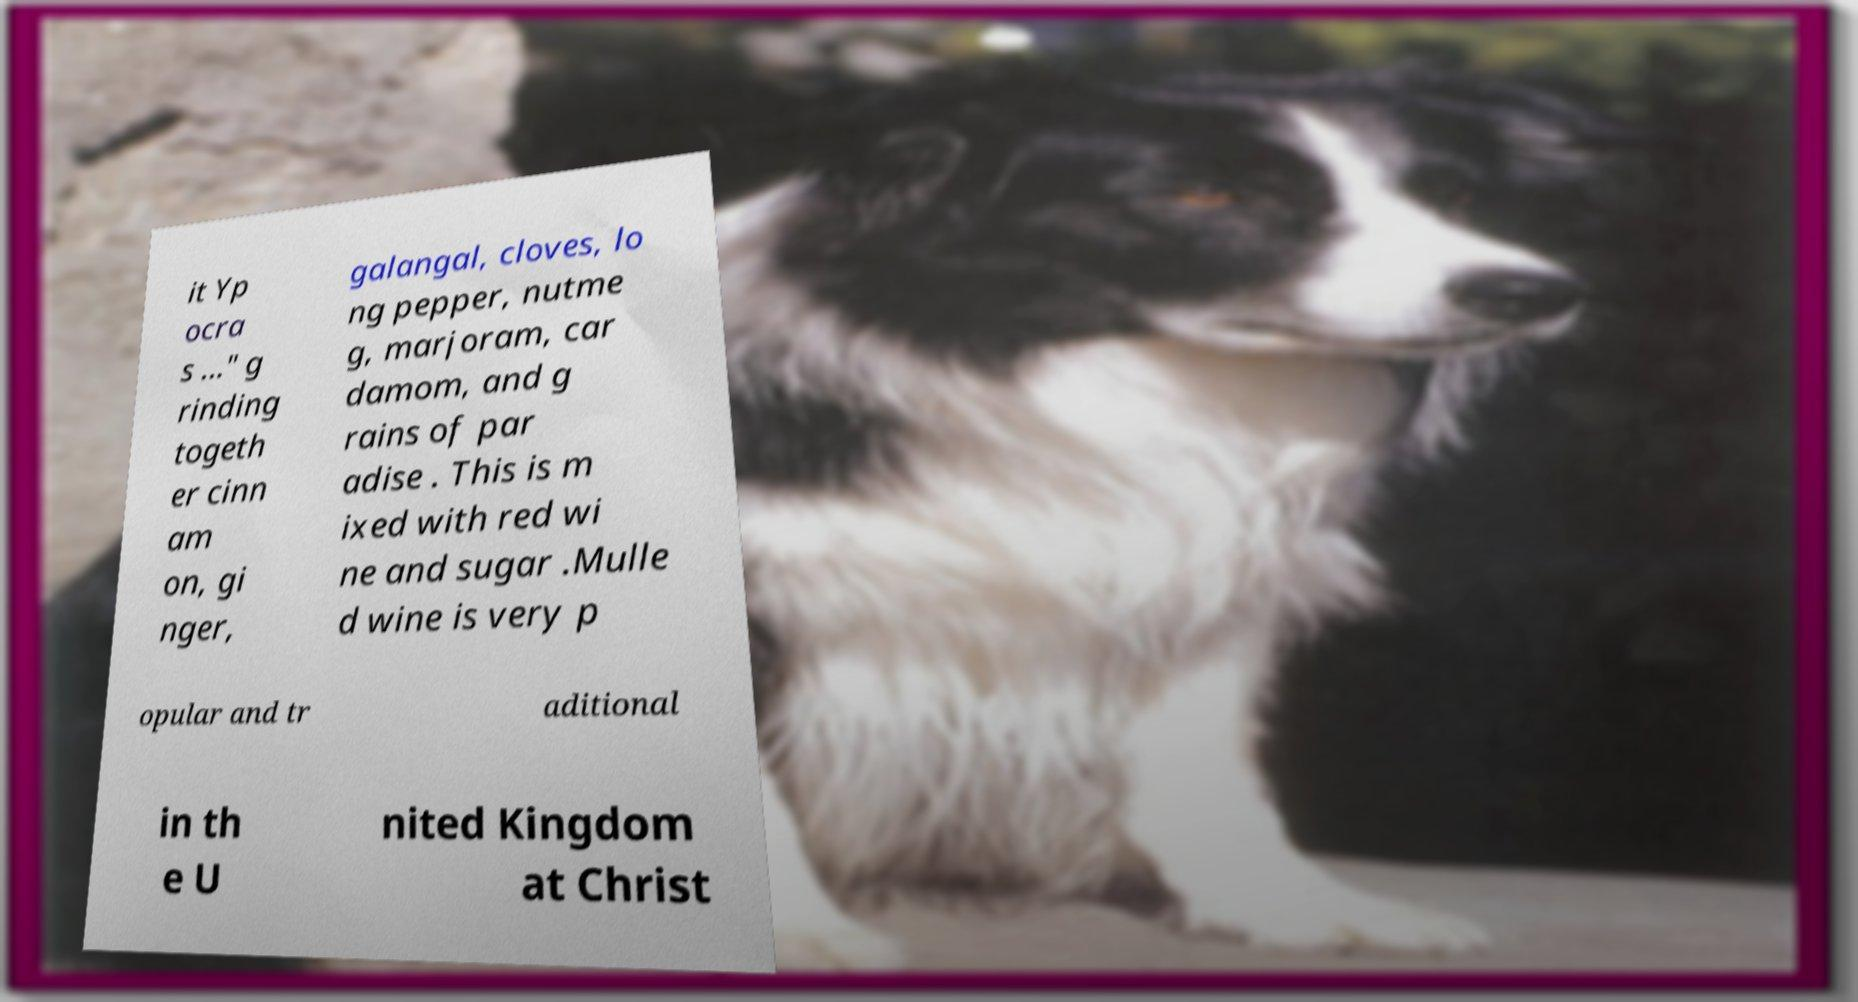Could you extract and type out the text from this image? it Yp ocra s ..." g rinding togeth er cinn am on, gi nger, galangal, cloves, lo ng pepper, nutme g, marjoram, car damom, and g rains of par adise . This is m ixed with red wi ne and sugar .Mulle d wine is very p opular and tr aditional in th e U nited Kingdom at Christ 